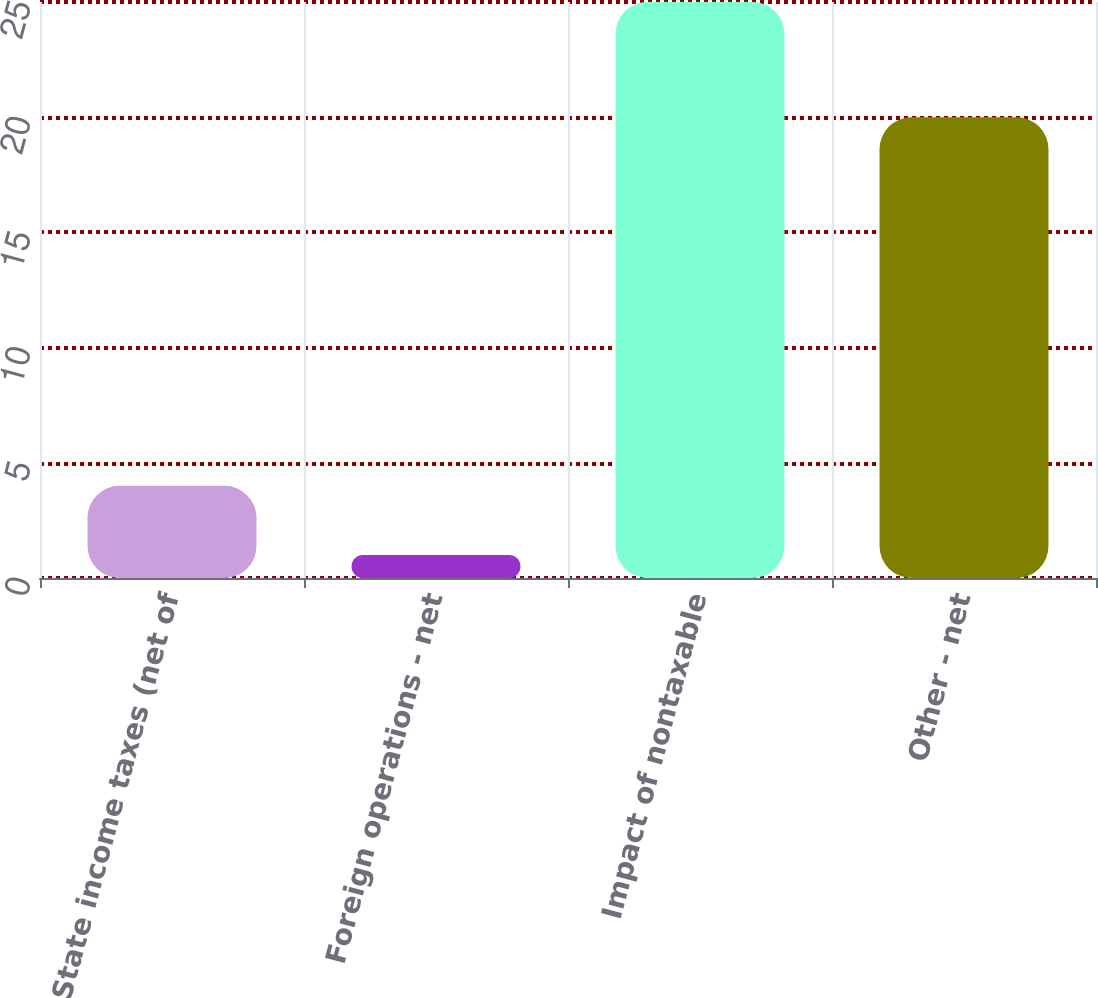Convert chart to OTSL. <chart><loc_0><loc_0><loc_500><loc_500><bar_chart><fcel>State income taxes (net of<fcel>Foreign operations - net<fcel>Impact of nontaxable<fcel>Other - net<nl><fcel>4<fcel>1<fcel>25<fcel>20<nl></chart> 